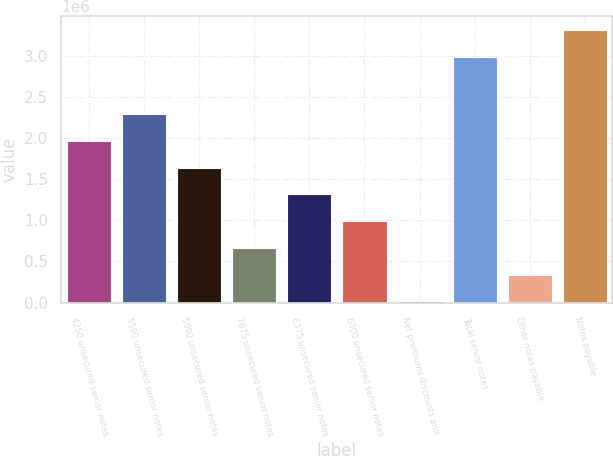Convert chart to OTSL. <chart><loc_0><loc_0><loc_500><loc_500><bar_chart><fcel>4250 unsecured senior notes<fcel>5500 unsecured senior notes<fcel>5000 unsecured senior notes<fcel>7875 unsecured senior notes<fcel>6375 unsecured senior notes<fcel>6000 unsecured senior notes<fcel>Net premiums discounts and<fcel>Total senior notes<fcel>Other notes payable<fcel>Notes payable<nl><fcel>1.96349e+06<fcel>2.28856e+06<fcel>1.63842e+06<fcel>663200<fcel>1.31334e+06<fcel>988272<fcel>13057<fcel>2.98694e+06<fcel>338129<fcel>3.31201e+06<nl></chart> 